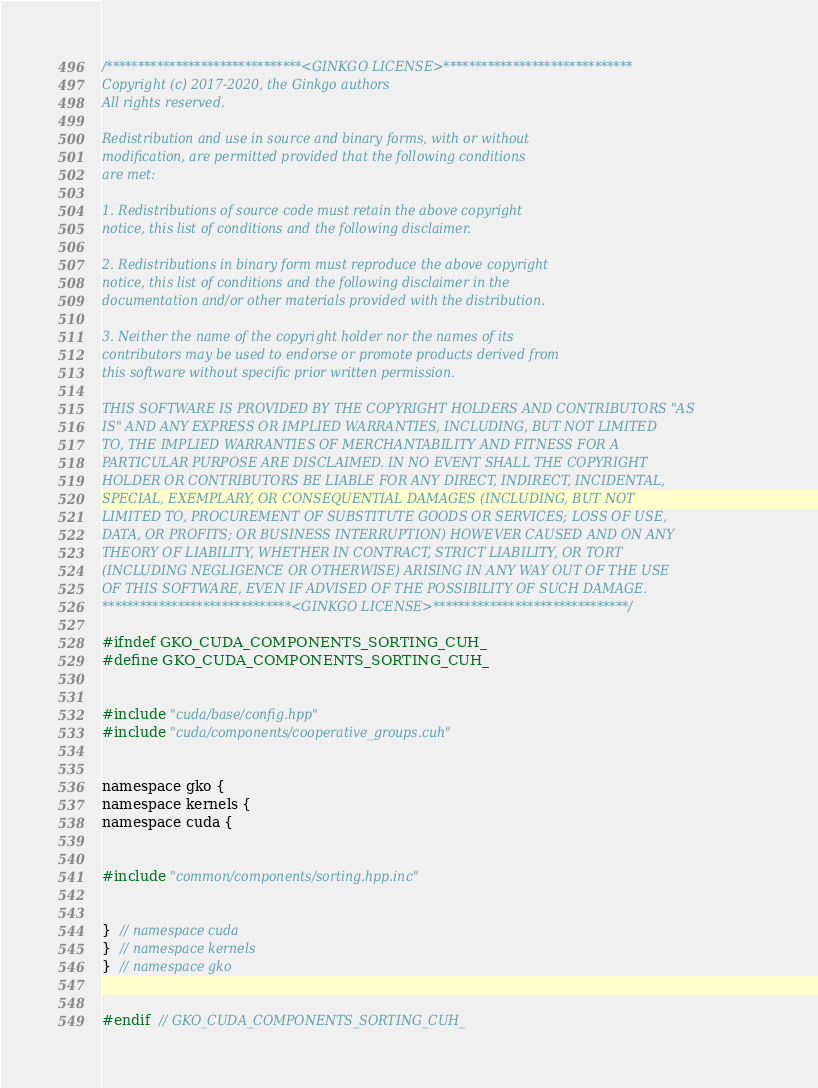Convert code to text. <code><loc_0><loc_0><loc_500><loc_500><_Cuda_>/*******************************<GINKGO LICENSE>******************************
Copyright (c) 2017-2020, the Ginkgo authors
All rights reserved.

Redistribution and use in source and binary forms, with or without
modification, are permitted provided that the following conditions
are met:

1. Redistributions of source code must retain the above copyright
notice, this list of conditions and the following disclaimer.

2. Redistributions in binary form must reproduce the above copyright
notice, this list of conditions and the following disclaimer in the
documentation and/or other materials provided with the distribution.

3. Neither the name of the copyright holder nor the names of its
contributors may be used to endorse or promote products derived from
this software without specific prior written permission.

THIS SOFTWARE IS PROVIDED BY THE COPYRIGHT HOLDERS AND CONTRIBUTORS "AS
IS" AND ANY EXPRESS OR IMPLIED WARRANTIES, INCLUDING, BUT NOT LIMITED
TO, THE IMPLIED WARRANTIES OF MERCHANTABILITY AND FITNESS FOR A
PARTICULAR PURPOSE ARE DISCLAIMED. IN NO EVENT SHALL THE COPYRIGHT
HOLDER OR CONTRIBUTORS BE LIABLE FOR ANY DIRECT, INDIRECT, INCIDENTAL,
SPECIAL, EXEMPLARY, OR CONSEQUENTIAL DAMAGES (INCLUDING, BUT NOT
LIMITED TO, PROCUREMENT OF SUBSTITUTE GOODS OR SERVICES; LOSS OF USE,
DATA, OR PROFITS; OR BUSINESS INTERRUPTION) HOWEVER CAUSED AND ON ANY
THEORY OF LIABILITY, WHETHER IN CONTRACT, STRICT LIABILITY, OR TORT
(INCLUDING NEGLIGENCE OR OTHERWISE) ARISING IN ANY WAY OUT OF THE USE
OF THIS SOFTWARE, EVEN IF ADVISED OF THE POSSIBILITY OF SUCH DAMAGE.
******************************<GINKGO LICENSE>*******************************/

#ifndef GKO_CUDA_COMPONENTS_SORTING_CUH_
#define GKO_CUDA_COMPONENTS_SORTING_CUH_


#include "cuda/base/config.hpp"
#include "cuda/components/cooperative_groups.cuh"


namespace gko {
namespace kernels {
namespace cuda {


#include "common/components/sorting.hpp.inc"


}  // namespace cuda
}  // namespace kernels
}  // namespace gko


#endif  // GKO_CUDA_COMPONENTS_SORTING_CUH_
</code> 